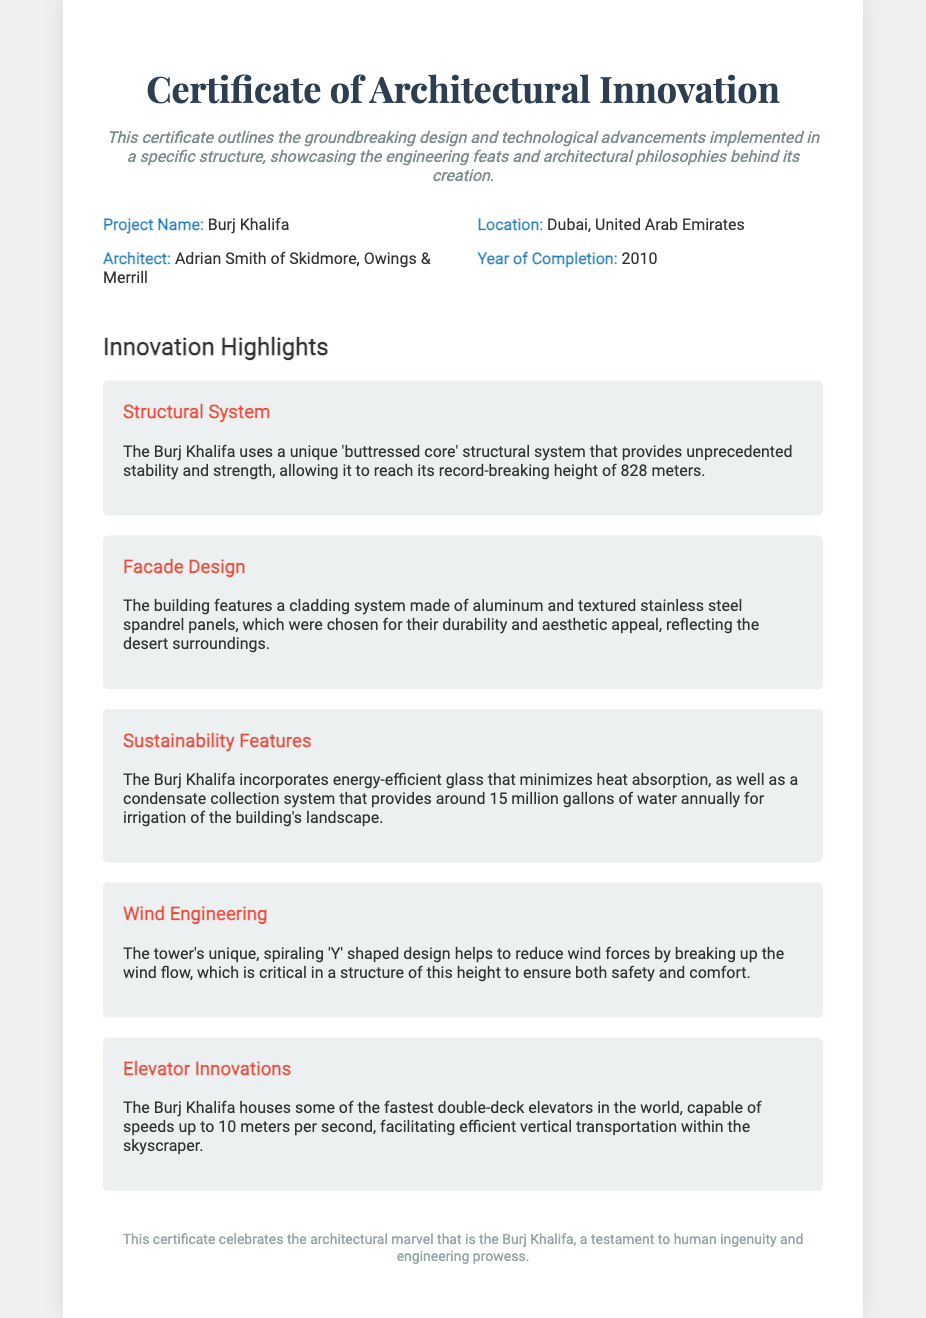What is the project name? The project name is explicitly stated in the project information section of the document.
Answer: Burj Khalifa Who is the architect? The architect's name is included in the project information, highlighting the designer of the structure.
Answer: Adrian Smith of Skidmore, Owings & Merrill What year was the Burj Khalifa completed? The year of completion is mentioned in the project information section of the document.
Answer: 2010 What unique structural system does the Burj Khalifa use? The document specifies the type of structural system utilized for the building's construction.
Answer: Buttressed core What feature minimizes heat absorption? The document mentions features that contribute to energy efficiency, focusing on minimizing heat absorption.
Answer: Energy-efficient glass How tall is the Burj Khalifa? The height of the building is noted in the description of its structural system in the innovations section.
Answer: 828 meters What design reduces wind forces? The document details the architectural design that helps mitigate wind forces on the structure.
Answer: Spiraling 'Y' shaped design What notable innovation is found in the elevators? The document highlights a specific characteristic of the building's elevators under innovations.
Answer: Fastest double-deck elevators What does the certificate celebrate? The footer of the document summarizes the overall message of the certificate.
Answer: Architectural marvel 